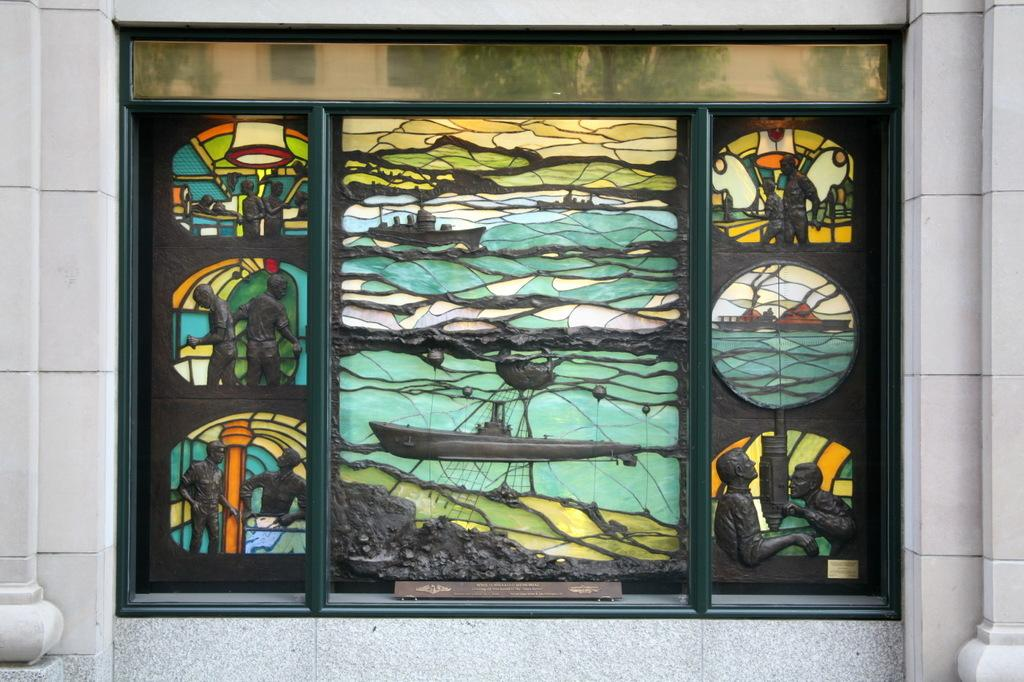What is the main feature of the image? There is a wall in the image. What is located in the middle of the image? There is an art piece in the middle of the image. What type of toe can be seen in the image? There are no toes present in the image. What kind of sail is visible in the image? There is no sail present in the image. 